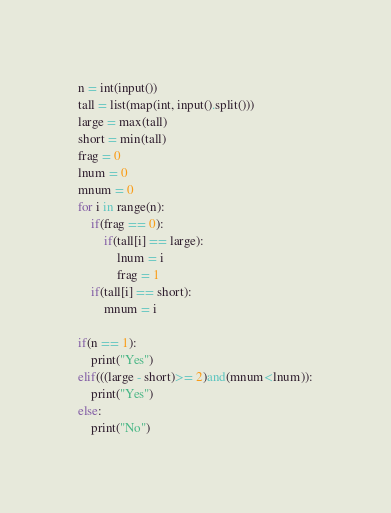Convert code to text. <code><loc_0><loc_0><loc_500><loc_500><_Python_>n = int(input())
tall = list(map(int, input().split()))
large = max(tall)
short = min(tall)
frag = 0
lnum = 0
mnum = 0
for i in range(n):
    if(frag == 0):
        if(tall[i] == large):
            lnum = i
            frag = 1
    if(tall[i] == short):
        mnum = i

if(n == 1):
    print("Yes")
elif(((large - short)>= 2)and(mnum<lnum)):
    print("Yes")
else:
    print("No")</code> 